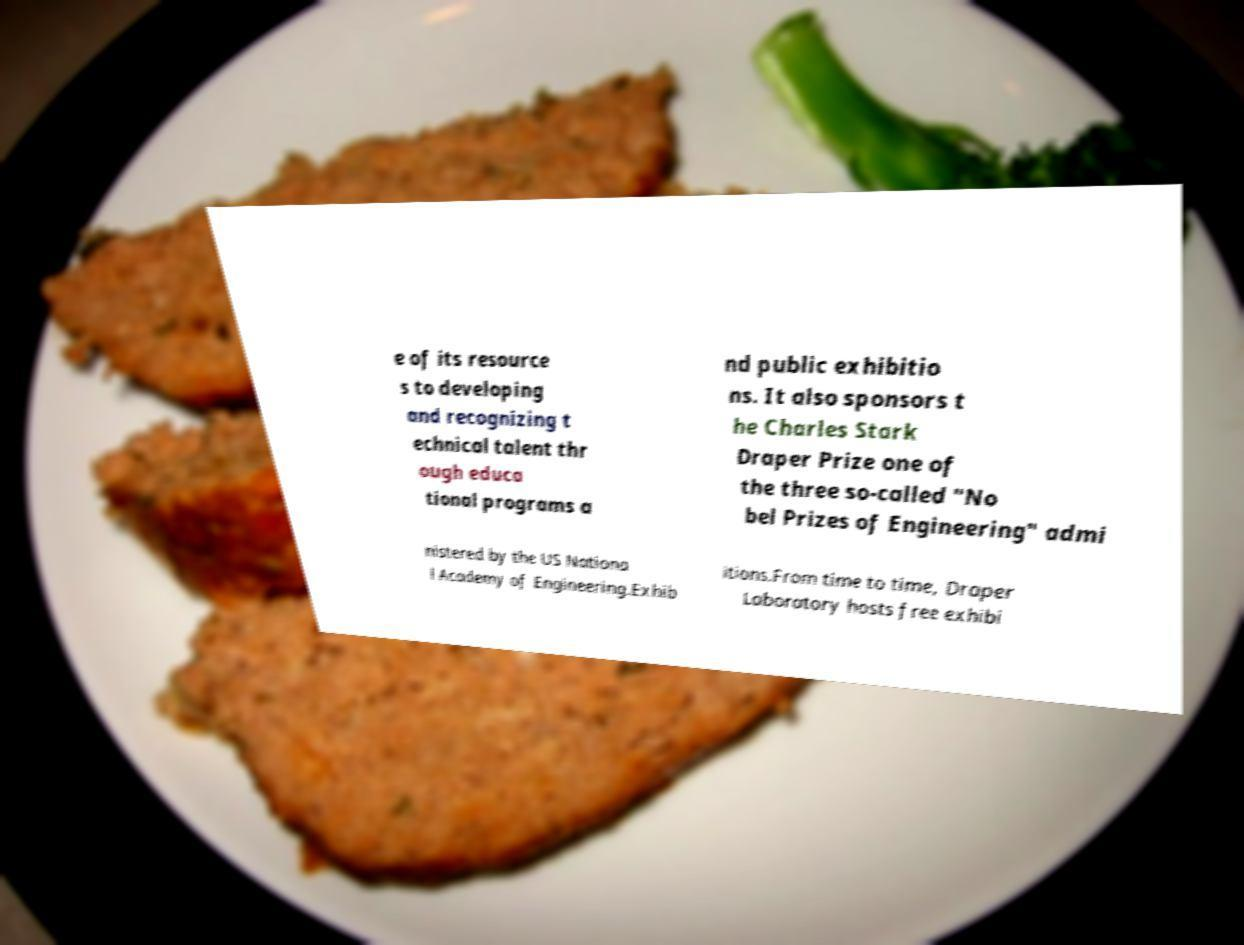Could you extract and type out the text from this image? e of its resource s to developing and recognizing t echnical talent thr ough educa tional programs a nd public exhibitio ns. It also sponsors t he Charles Stark Draper Prize one of the three so-called "No bel Prizes of Engineering" admi nistered by the US Nationa l Academy of Engineering.Exhib itions.From time to time, Draper Laboratory hosts free exhibi 